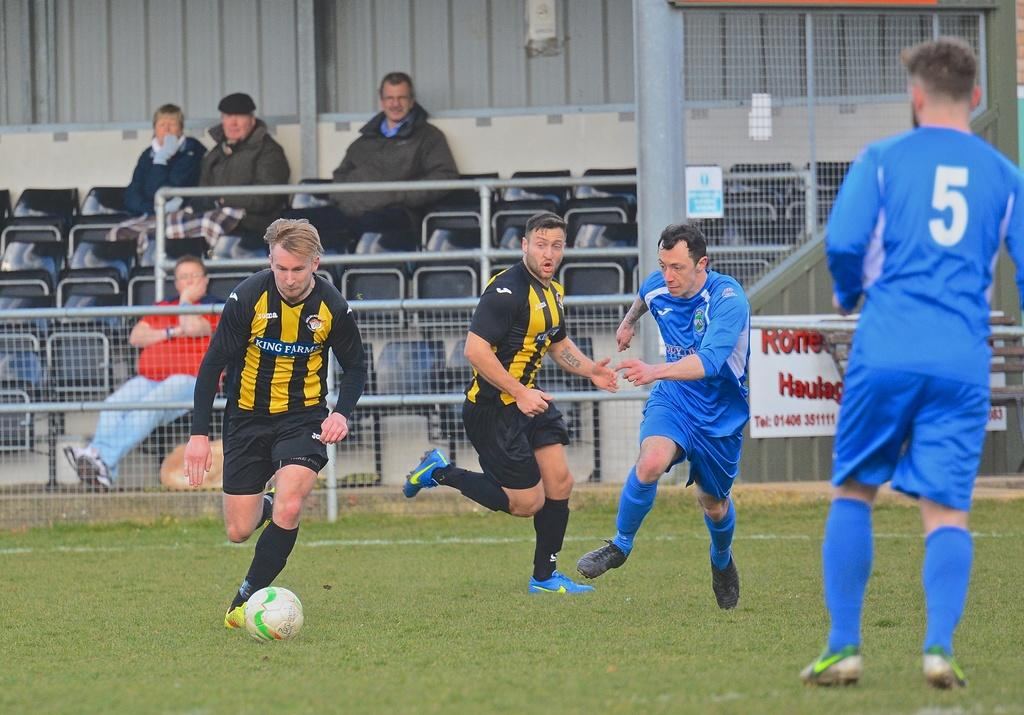<image>
Summarize the visual content of the image. A man in a King Farms soccer jersey kicks a soccer ball at a game. 